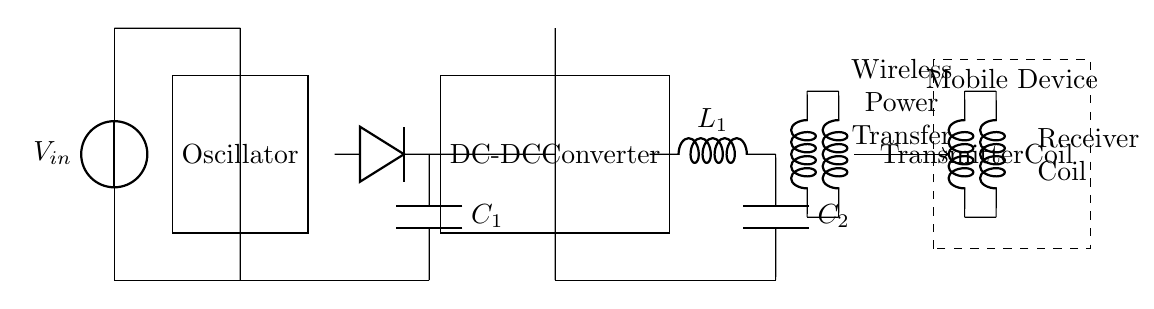What kind of voltage source is used in this circuit? The circuit uses a voltage source labeled as V_in, which indicates the presence of an input voltage needed to power the circuit.
Answer: V_in What is the role of the oscillator in this circuit? The oscillator generates a specific frequency needed for the wireless charging process, which is crucial for the operation of the transmitter coil.
Answer: Oscillator What component is used to convert AC to DC? The circuit includes a diode, which is connected to a capacitor to rectify the alternating current generated by the oscillator into direct current.
Answer: Diode How many coils are present in the wireless charging circuit? There are two coils in the circuit: a transmitter coil that emits power and a receiver coil that captures the transmitted power to charge the mobile device.
Answer: Two What is the purpose of the DC-DC converter? The DC-DC converter adjusts the output voltage to a specific level suitable for charging the mobile device, ensuring the proper charging current flows into the device.
Answer: Adjust voltage What component represents energy storage in the circuit? The capacitors, labeled C_1 and C_2, serve as energy storage elements and help smooth out the voltage supply to both the rectifier and the output stage.
Answer: Capacitors What is transferred wirelessly in this circuit? The wireless power transfer section indicates that electrical energy is transferred from the transmitter coil to the receiver coil without direct physical connections.
Answer: Electrical energy 